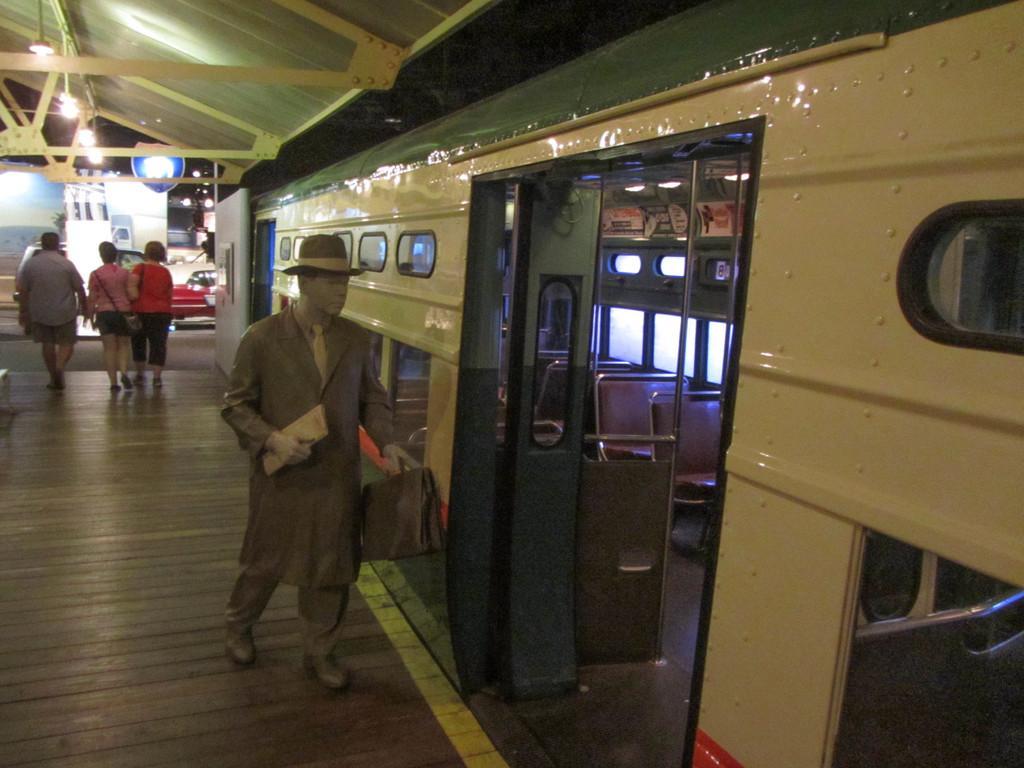Can you describe this image briefly? In the image we can see there are people walking, wearing clothes and some people are carrying a bag. Here we can see the train, footpath and lights. We can even see the building and the vehicle. 